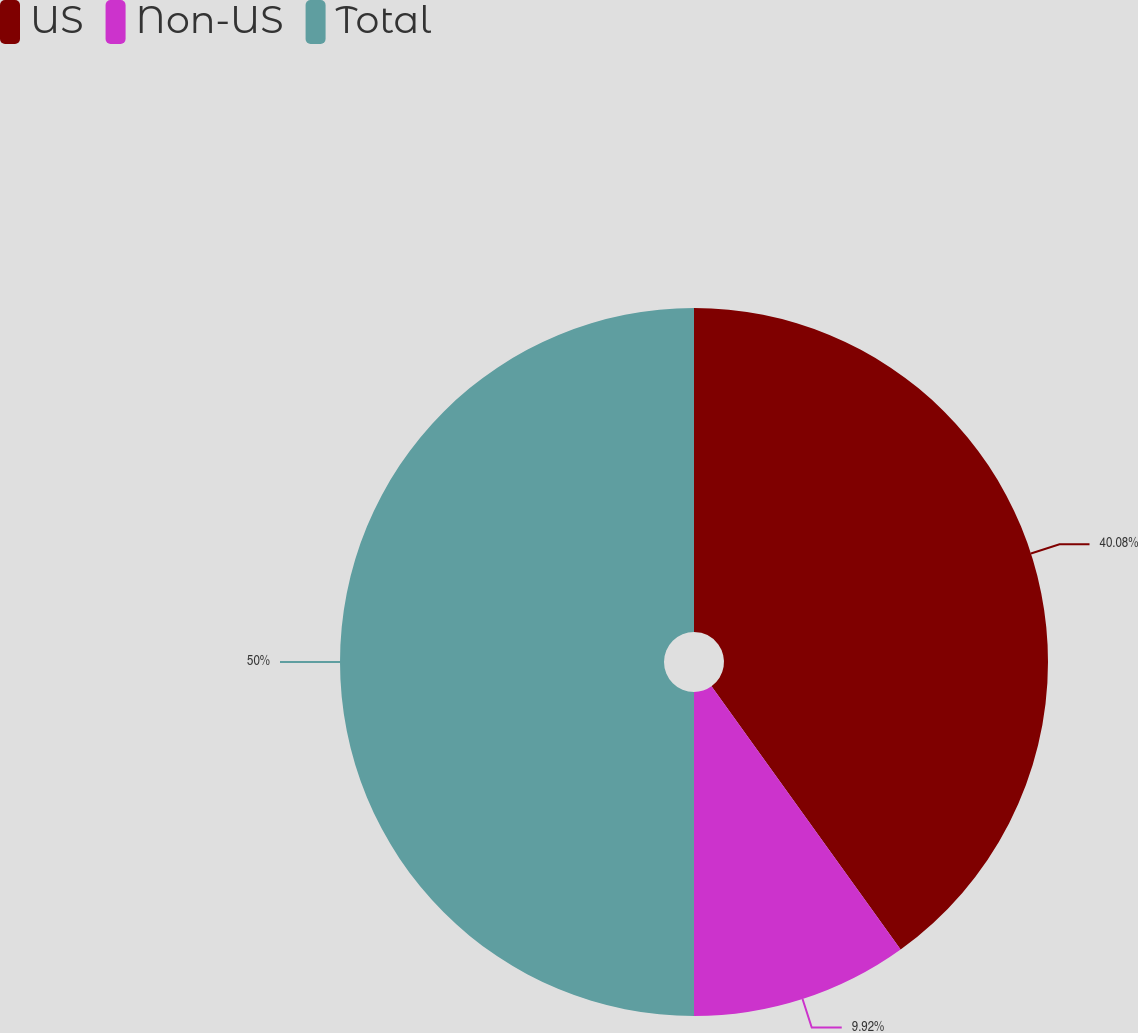Convert chart. <chart><loc_0><loc_0><loc_500><loc_500><pie_chart><fcel>US<fcel>Non-US<fcel>Total<nl><fcel>40.08%<fcel>9.92%<fcel>50.0%<nl></chart> 